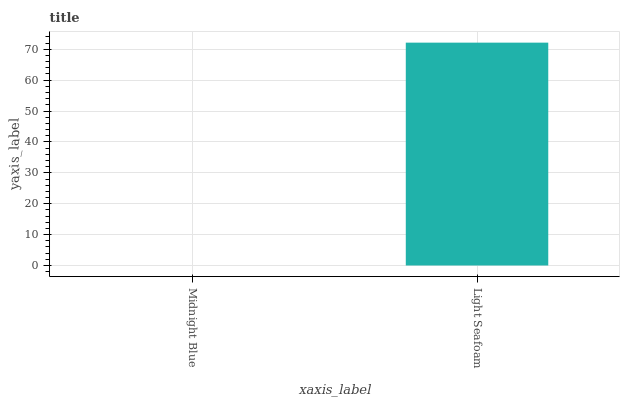Is Midnight Blue the minimum?
Answer yes or no. Yes. Is Light Seafoam the maximum?
Answer yes or no. Yes. Is Light Seafoam the minimum?
Answer yes or no. No. Is Light Seafoam greater than Midnight Blue?
Answer yes or no. Yes. Is Midnight Blue less than Light Seafoam?
Answer yes or no. Yes. Is Midnight Blue greater than Light Seafoam?
Answer yes or no. No. Is Light Seafoam less than Midnight Blue?
Answer yes or no. No. Is Light Seafoam the high median?
Answer yes or no. Yes. Is Midnight Blue the low median?
Answer yes or no. Yes. Is Midnight Blue the high median?
Answer yes or no. No. Is Light Seafoam the low median?
Answer yes or no. No. 